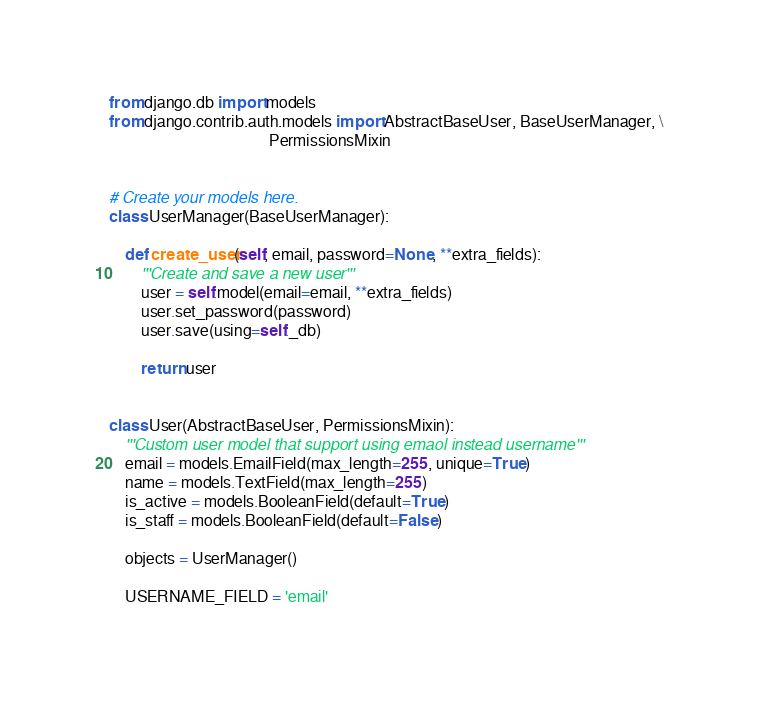<code> <loc_0><loc_0><loc_500><loc_500><_Python_>from django.db import models
from django.contrib.auth.models import AbstractBaseUser, BaseUserManager, \
                                        PermissionsMixin


# Create your models here.
class UserManager(BaseUserManager):

    def create_user(self, email, password=None, **extra_fields):
        '''Create and save a new user'''
        user = self.model(email=email, **extra_fields)
        user.set_password(password)
        user.save(using=self._db)

        return user


class User(AbstractBaseUser, PermissionsMixin):
    '''Custom user model that support using emaol instead username'''
    email = models.EmailField(max_length=255, unique=True)
    name = models.TextField(max_length=255)
    is_active = models.BooleanField(default=True)
    is_staff = models.BooleanField(default=False)

    objects = UserManager()

    USERNAME_FIELD = 'email'
</code> 